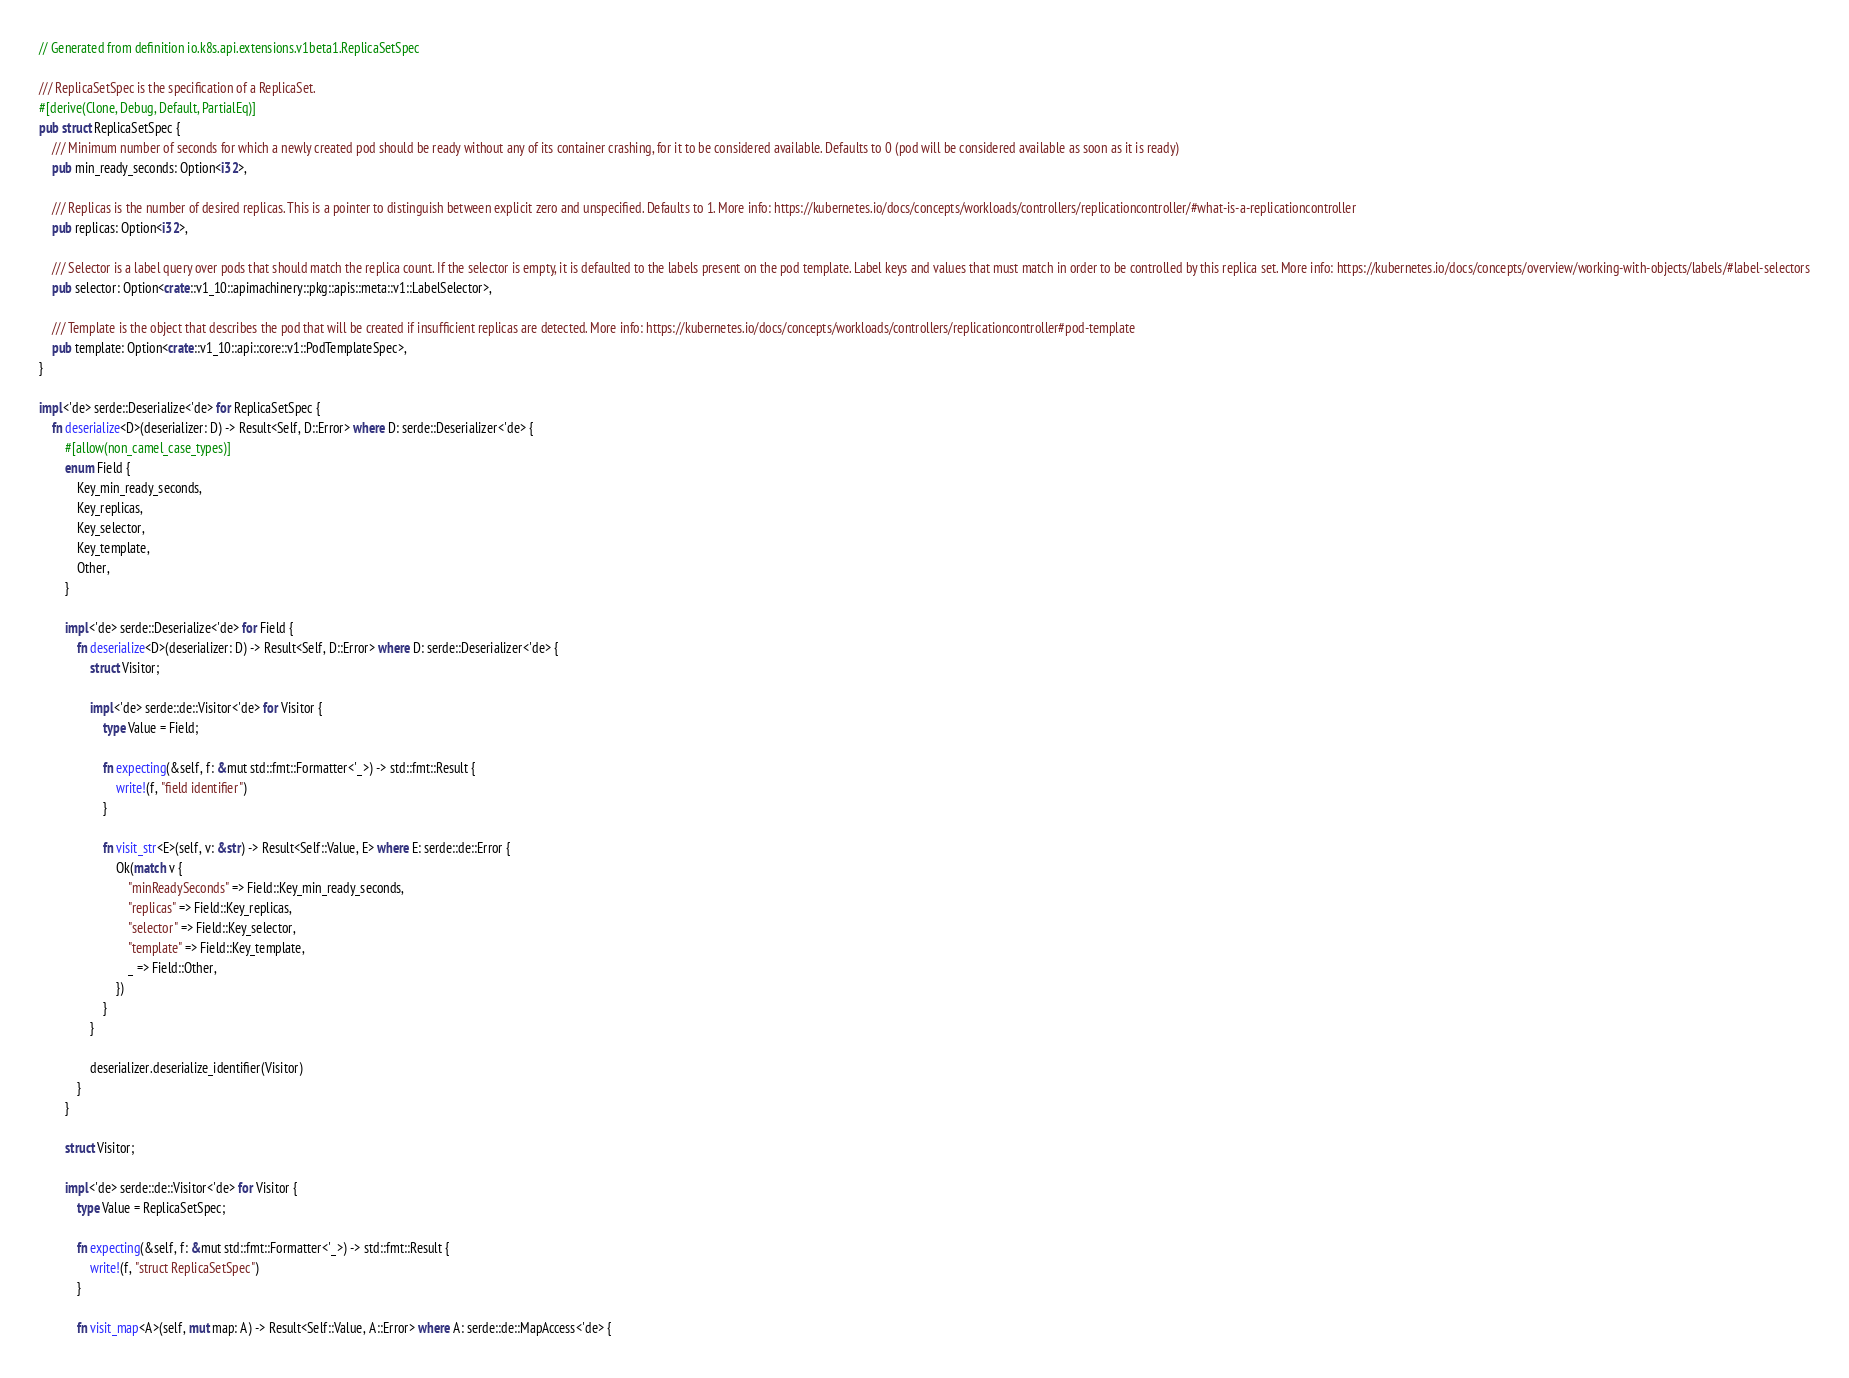<code> <loc_0><loc_0><loc_500><loc_500><_Rust_>// Generated from definition io.k8s.api.extensions.v1beta1.ReplicaSetSpec

/// ReplicaSetSpec is the specification of a ReplicaSet.
#[derive(Clone, Debug, Default, PartialEq)]
pub struct ReplicaSetSpec {
    /// Minimum number of seconds for which a newly created pod should be ready without any of its container crashing, for it to be considered available. Defaults to 0 (pod will be considered available as soon as it is ready)
    pub min_ready_seconds: Option<i32>,

    /// Replicas is the number of desired replicas. This is a pointer to distinguish between explicit zero and unspecified. Defaults to 1. More info: https://kubernetes.io/docs/concepts/workloads/controllers/replicationcontroller/#what-is-a-replicationcontroller
    pub replicas: Option<i32>,

    /// Selector is a label query over pods that should match the replica count. If the selector is empty, it is defaulted to the labels present on the pod template. Label keys and values that must match in order to be controlled by this replica set. More info: https://kubernetes.io/docs/concepts/overview/working-with-objects/labels/#label-selectors
    pub selector: Option<crate::v1_10::apimachinery::pkg::apis::meta::v1::LabelSelector>,

    /// Template is the object that describes the pod that will be created if insufficient replicas are detected. More info: https://kubernetes.io/docs/concepts/workloads/controllers/replicationcontroller#pod-template
    pub template: Option<crate::v1_10::api::core::v1::PodTemplateSpec>,
}

impl<'de> serde::Deserialize<'de> for ReplicaSetSpec {
    fn deserialize<D>(deserializer: D) -> Result<Self, D::Error> where D: serde::Deserializer<'de> {
        #[allow(non_camel_case_types)]
        enum Field {
            Key_min_ready_seconds,
            Key_replicas,
            Key_selector,
            Key_template,
            Other,
        }

        impl<'de> serde::Deserialize<'de> for Field {
            fn deserialize<D>(deserializer: D) -> Result<Self, D::Error> where D: serde::Deserializer<'de> {
                struct Visitor;

                impl<'de> serde::de::Visitor<'de> for Visitor {
                    type Value = Field;

                    fn expecting(&self, f: &mut std::fmt::Formatter<'_>) -> std::fmt::Result {
                        write!(f, "field identifier")
                    }

                    fn visit_str<E>(self, v: &str) -> Result<Self::Value, E> where E: serde::de::Error {
                        Ok(match v {
                            "minReadySeconds" => Field::Key_min_ready_seconds,
                            "replicas" => Field::Key_replicas,
                            "selector" => Field::Key_selector,
                            "template" => Field::Key_template,
                            _ => Field::Other,
                        })
                    }
                }

                deserializer.deserialize_identifier(Visitor)
            }
        }

        struct Visitor;

        impl<'de> serde::de::Visitor<'de> for Visitor {
            type Value = ReplicaSetSpec;

            fn expecting(&self, f: &mut std::fmt::Formatter<'_>) -> std::fmt::Result {
                write!(f, "struct ReplicaSetSpec")
            }

            fn visit_map<A>(self, mut map: A) -> Result<Self::Value, A::Error> where A: serde::de::MapAccess<'de> {</code> 